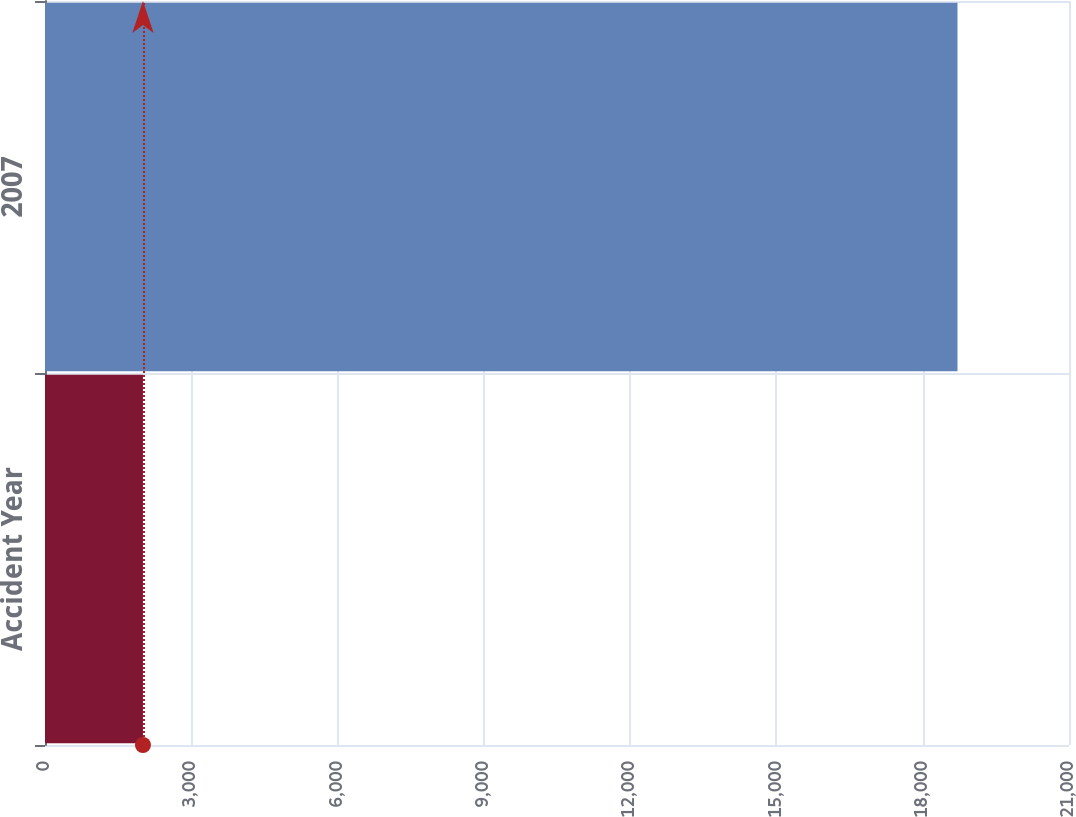Convert chart. <chart><loc_0><loc_0><loc_500><loc_500><bar_chart><fcel>Accident Year<fcel>2007<nl><fcel>2009<fcel>18713<nl></chart> 